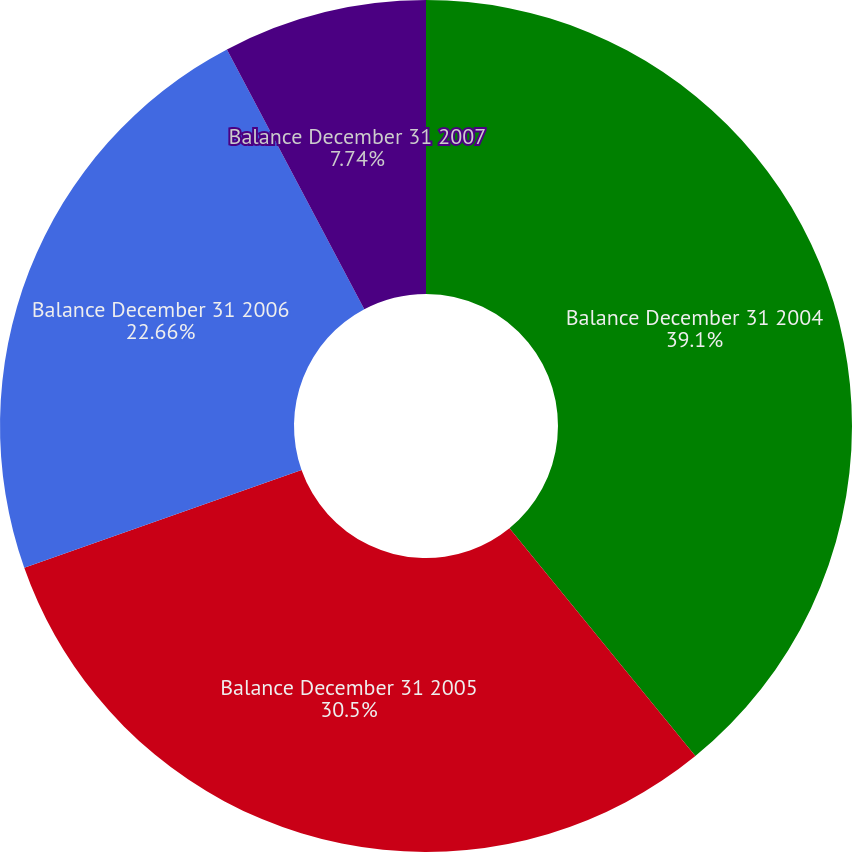<chart> <loc_0><loc_0><loc_500><loc_500><pie_chart><fcel>Balance December 31 2004<fcel>Balance December 31 2005<fcel>Balance December 31 2006<fcel>Balance December 31 2007<nl><fcel>39.11%<fcel>30.5%<fcel>22.66%<fcel>7.74%<nl></chart> 